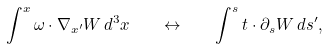Convert formula to latex. <formula><loc_0><loc_0><loc_500><loc_500>\int ^ { x } \omega \cdot \nabla _ { x ^ { \prime } } W \, d ^ { 3 } x \quad \leftrightarrow \quad \int ^ { s } t \cdot \partial _ { s } W \, d s ^ { \prime } ,</formula> 